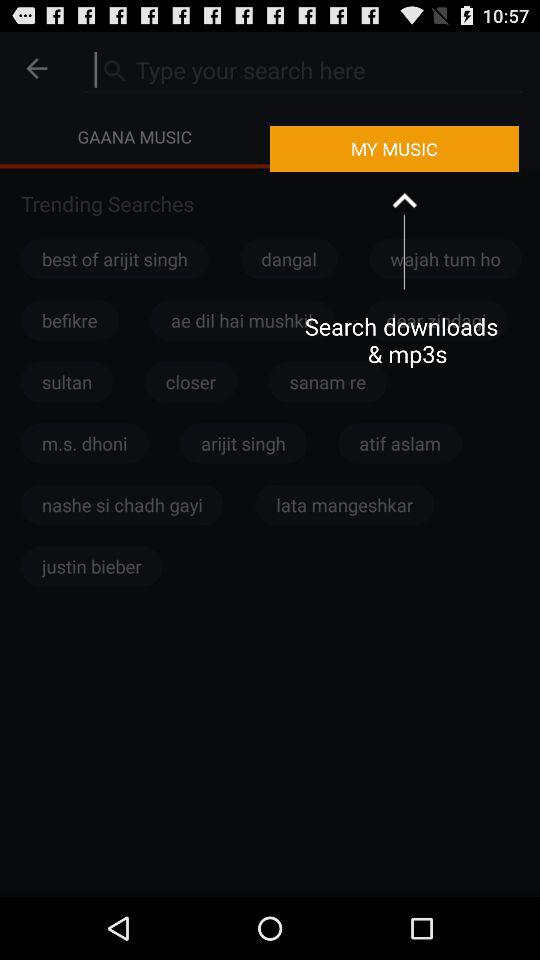Which tab is selected? The selected tab is "MY MUSIC". 